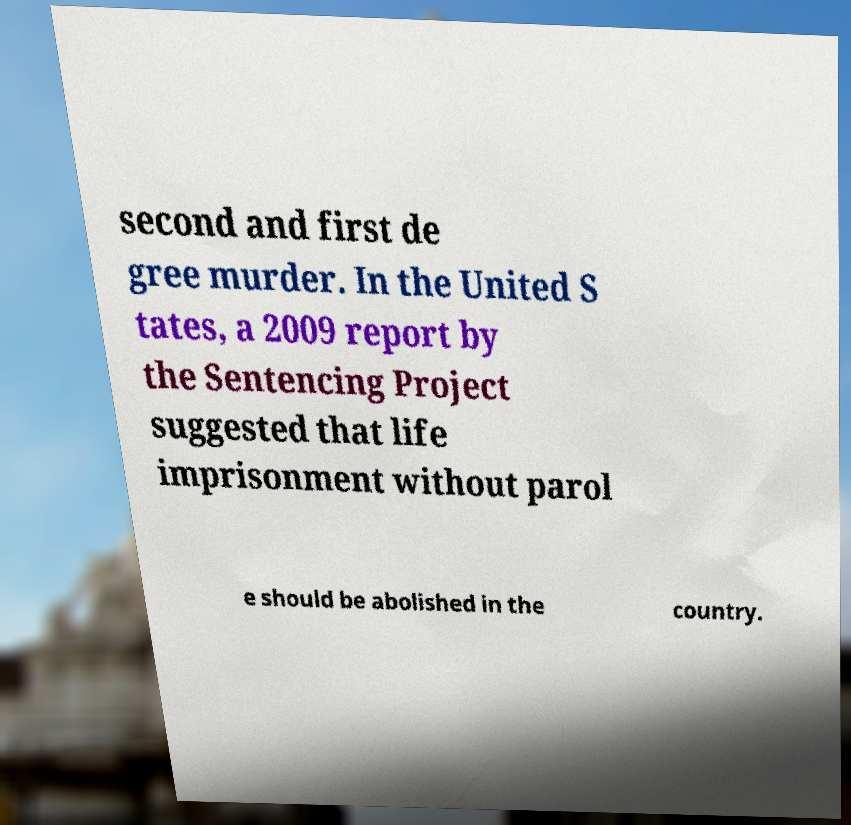Could you extract and type out the text from this image? second and first de gree murder. In the United S tates, a 2009 report by the Sentencing Project suggested that life imprisonment without parol e should be abolished in the country. 